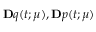Convert formula to latex. <formula><loc_0><loc_0><loc_500><loc_500>{ \mathbf q } ( t ; { \boldsymbol \mu } ) , { \mathbf p } ( t ; { \boldsymbol \mu } )</formula> 